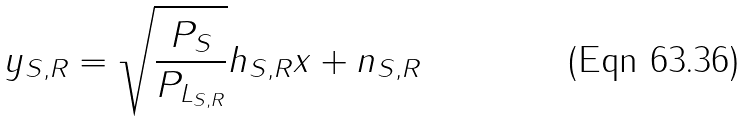<formula> <loc_0><loc_0><loc_500><loc_500>y _ { S , R } = \sqrt { \frac { P _ { S } } { P _ { L _ { S , R } } } } h _ { S , R } x + n _ { S , R }</formula> 